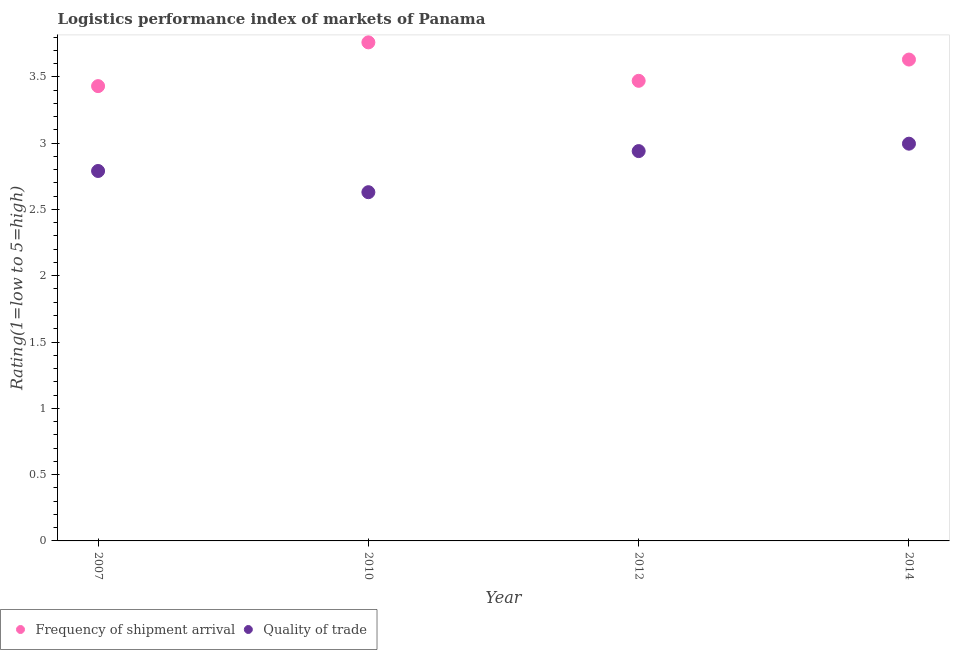What is the lpi quality of trade in 2012?
Your answer should be very brief. 2.94. Across all years, what is the maximum lpi quality of trade?
Provide a succinct answer. 3. Across all years, what is the minimum lpi quality of trade?
Ensure brevity in your answer.  2.63. In which year was the lpi quality of trade maximum?
Offer a terse response. 2014. In which year was the lpi quality of trade minimum?
Ensure brevity in your answer.  2010. What is the total lpi quality of trade in the graph?
Offer a very short reply. 11.36. What is the difference between the lpi of frequency of shipment arrival in 2010 and that in 2012?
Your answer should be very brief. 0.29. What is the difference between the lpi quality of trade in 2014 and the lpi of frequency of shipment arrival in 2012?
Provide a succinct answer. -0.47. What is the average lpi quality of trade per year?
Make the answer very short. 2.84. In the year 2007, what is the difference between the lpi quality of trade and lpi of frequency of shipment arrival?
Your answer should be very brief. -0.64. In how many years, is the lpi quality of trade greater than 0.7?
Make the answer very short. 4. What is the ratio of the lpi of frequency of shipment arrival in 2007 to that in 2010?
Your answer should be compact. 0.91. What is the difference between the highest and the second highest lpi of frequency of shipment arrival?
Your answer should be very brief. 0.13. What is the difference between the highest and the lowest lpi quality of trade?
Give a very brief answer. 0.37. Does the lpi quality of trade monotonically increase over the years?
Your answer should be compact. No. Is the lpi of frequency of shipment arrival strictly less than the lpi quality of trade over the years?
Your answer should be very brief. No. How many dotlines are there?
Your response must be concise. 2. How many years are there in the graph?
Your answer should be compact. 4. What is the difference between two consecutive major ticks on the Y-axis?
Provide a succinct answer. 0.5. Does the graph contain any zero values?
Offer a terse response. No. Does the graph contain grids?
Your answer should be compact. No. What is the title of the graph?
Offer a very short reply. Logistics performance index of markets of Panama. What is the label or title of the Y-axis?
Your answer should be compact. Rating(1=low to 5=high). What is the Rating(1=low to 5=high) of Frequency of shipment arrival in 2007?
Provide a succinct answer. 3.43. What is the Rating(1=low to 5=high) of Quality of trade in 2007?
Provide a short and direct response. 2.79. What is the Rating(1=low to 5=high) in Frequency of shipment arrival in 2010?
Keep it short and to the point. 3.76. What is the Rating(1=low to 5=high) in Quality of trade in 2010?
Your response must be concise. 2.63. What is the Rating(1=low to 5=high) in Frequency of shipment arrival in 2012?
Make the answer very short. 3.47. What is the Rating(1=low to 5=high) of Quality of trade in 2012?
Keep it short and to the point. 2.94. What is the Rating(1=low to 5=high) of Frequency of shipment arrival in 2014?
Provide a succinct answer. 3.63. What is the Rating(1=low to 5=high) of Quality of trade in 2014?
Give a very brief answer. 3. Across all years, what is the maximum Rating(1=low to 5=high) of Frequency of shipment arrival?
Offer a very short reply. 3.76. Across all years, what is the maximum Rating(1=low to 5=high) in Quality of trade?
Keep it short and to the point. 3. Across all years, what is the minimum Rating(1=low to 5=high) of Frequency of shipment arrival?
Ensure brevity in your answer.  3.43. Across all years, what is the minimum Rating(1=low to 5=high) in Quality of trade?
Offer a terse response. 2.63. What is the total Rating(1=low to 5=high) in Frequency of shipment arrival in the graph?
Provide a succinct answer. 14.29. What is the total Rating(1=low to 5=high) of Quality of trade in the graph?
Keep it short and to the point. 11.36. What is the difference between the Rating(1=low to 5=high) of Frequency of shipment arrival in 2007 and that in 2010?
Provide a short and direct response. -0.33. What is the difference between the Rating(1=low to 5=high) in Quality of trade in 2007 and that in 2010?
Ensure brevity in your answer.  0.16. What is the difference between the Rating(1=low to 5=high) of Frequency of shipment arrival in 2007 and that in 2012?
Make the answer very short. -0.04. What is the difference between the Rating(1=low to 5=high) in Quality of trade in 2007 and that in 2012?
Your response must be concise. -0.15. What is the difference between the Rating(1=low to 5=high) in Frequency of shipment arrival in 2007 and that in 2014?
Make the answer very short. -0.2. What is the difference between the Rating(1=low to 5=high) of Quality of trade in 2007 and that in 2014?
Ensure brevity in your answer.  -0.21. What is the difference between the Rating(1=low to 5=high) in Frequency of shipment arrival in 2010 and that in 2012?
Your answer should be very brief. 0.29. What is the difference between the Rating(1=low to 5=high) of Quality of trade in 2010 and that in 2012?
Offer a terse response. -0.31. What is the difference between the Rating(1=low to 5=high) in Frequency of shipment arrival in 2010 and that in 2014?
Offer a terse response. 0.13. What is the difference between the Rating(1=low to 5=high) in Quality of trade in 2010 and that in 2014?
Your answer should be compact. -0.37. What is the difference between the Rating(1=low to 5=high) of Frequency of shipment arrival in 2012 and that in 2014?
Offer a terse response. -0.16. What is the difference between the Rating(1=low to 5=high) in Quality of trade in 2012 and that in 2014?
Make the answer very short. -0.06. What is the difference between the Rating(1=low to 5=high) of Frequency of shipment arrival in 2007 and the Rating(1=low to 5=high) of Quality of trade in 2012?
Your answer should be compact. 0.49. What is the difference between the Rating(1=low to 5=high) of Frequency of shipment arrival in 2007 and the Rating(1=low to 5=high) of Quality of trade in 2014?
Keep it short and to the point. 0.43. What is the difference between the Rating(1=low to 5=high) of Frequency of shipment arrival in 2010 and the Rating(1=low to 5=high) of Quality of trade in 2012?
Offer a terse response. 0.82. What is the difference between the Rating(1=low to 5=high) in Frequency of shipment arrival in 2010 and the Rating(1=low to 5=high) in Quality of trade in 2014?
Your response must be concise. 0.76. What is the difference between the Rating(1=low to 5=high) in Frequency of shipment arrival in 2012 and the Rating(1=low to 5=high) in Quality of trade in 2014?
Give a very brief answer. 0.47. What is the average Rating(1=low to 5=high) in Frequency of shipment arrival per year?
Provide a short and direct response. 3.57. What is the average Rating(1=low to 5=high) in Quality of trade per year?
Your answer should be compact. 2.84. In the year 2007, what is the difference between the Rating(1=low to 5=high) in Frequency of shipment arrival and Rating(1=low to 5=high) in Quality of trade?
Give a very brief answer. 0.64. In the year 2010, what is the difference between the Rating(1=low to 5=high) of Frequency of shipment arrival and Rating(1=low to 5=high) of Quality of trade?
Your response must be concise. 1.13. In the year 2012, what is the difference between the Rating(1=low to 5=high) in Frequency of shipment arrival and Rating(1=low to 5=high) in Quality of trade?
Ensure brevity in your answer.  0.53. In the year 2014, what is the difference between the Rating(1=low to 5=high) in Frequency of shipment arrival and Rating(1=low to 5=high) in Quality of trade?
Provide a succinct answer. 0.63. What is the ratio of the Rating(1=low to 5=high) of Frequency of shipment arrival in 2007 to that in 2010?
Offer a very short reply. 0.91. What is the ratio of the Rating(1=low to 5=high) in Quality of trade in 2007 to that in 2010?
Your response must be concise. 1.06. What is the ratio of the Rating(1=low to 5=high) in Frequency of shipment arrival in 2007 to that in 2012?
Offer a very short reply. 0.99. What is the ratio of the Rating(1=low to 5=high) in Quality of trade in 2007 to that in 2012?
Offer a very short reply. 0.95. What is the ratio of the Rating(1=low to 5=high) of Frequency of shipment arrival in 2007 to that in 2014?
Give a very brief answer. 0.94. What is the ratio of the Rating(1=low to 5=high) of Quality of trade in 2007 to that in 2014?
Provide a short and direct response. 0.93. What is the ratio of the Rating(1=low to 5=high) of Frequency of shipment arrival in 2010 to that in 2012?
Provide a short and direct response. 1.08. What is the ratio of the Rating(1=low to 5=high) of Quality of trade in 2010 to that in 2012?
Make the answer very short. 0.89. What is the ratio of the Rating(1=low to 5=high) in Frequency of shipment arrival in 2010 to that in 2014?
Give a very brief answer. 1.04. What is the ratio of the Rating(1=low to 5=high) of Quality of trade in 2010 to that in 2014?
Make the answer very short. 0.88. What is the ratio of the Rating(1=low to 5=high) in Frequency of shipment arrival in 2012 to that in 2014?
Offer a terse response. 0.96. What is the ratio of the Rating(1=low to 5=high) of Quality of trade in 2012 to that in 2014?
Offer a very short reply. 0.98. What is the difference between the highest and the second highest Rating(1=low to 5=high) in Frequency of shipment arrival?
Provide a succinct answer. 0.13. What is the difference between the highest and the second highest Rating(1=low to 5=high) in Quality of trade?
Give a very brief answer. 0.06. What is the difference between the highest and the lowest Rating(1=low to 5=high) of Frequency of shipment arrival?
Your answer should be compact. 0.33. What is the difference between the highest and the lowest Rating(1=low to 5=high) in Quality of trade?
Keep it short and to the point. 0.37. 